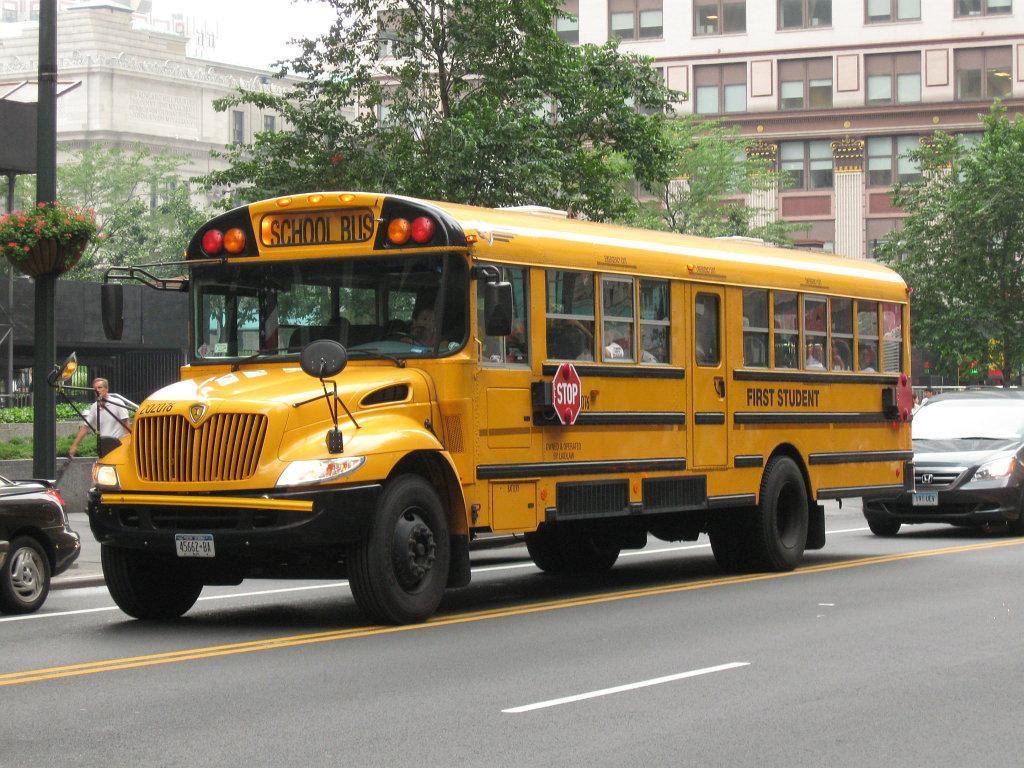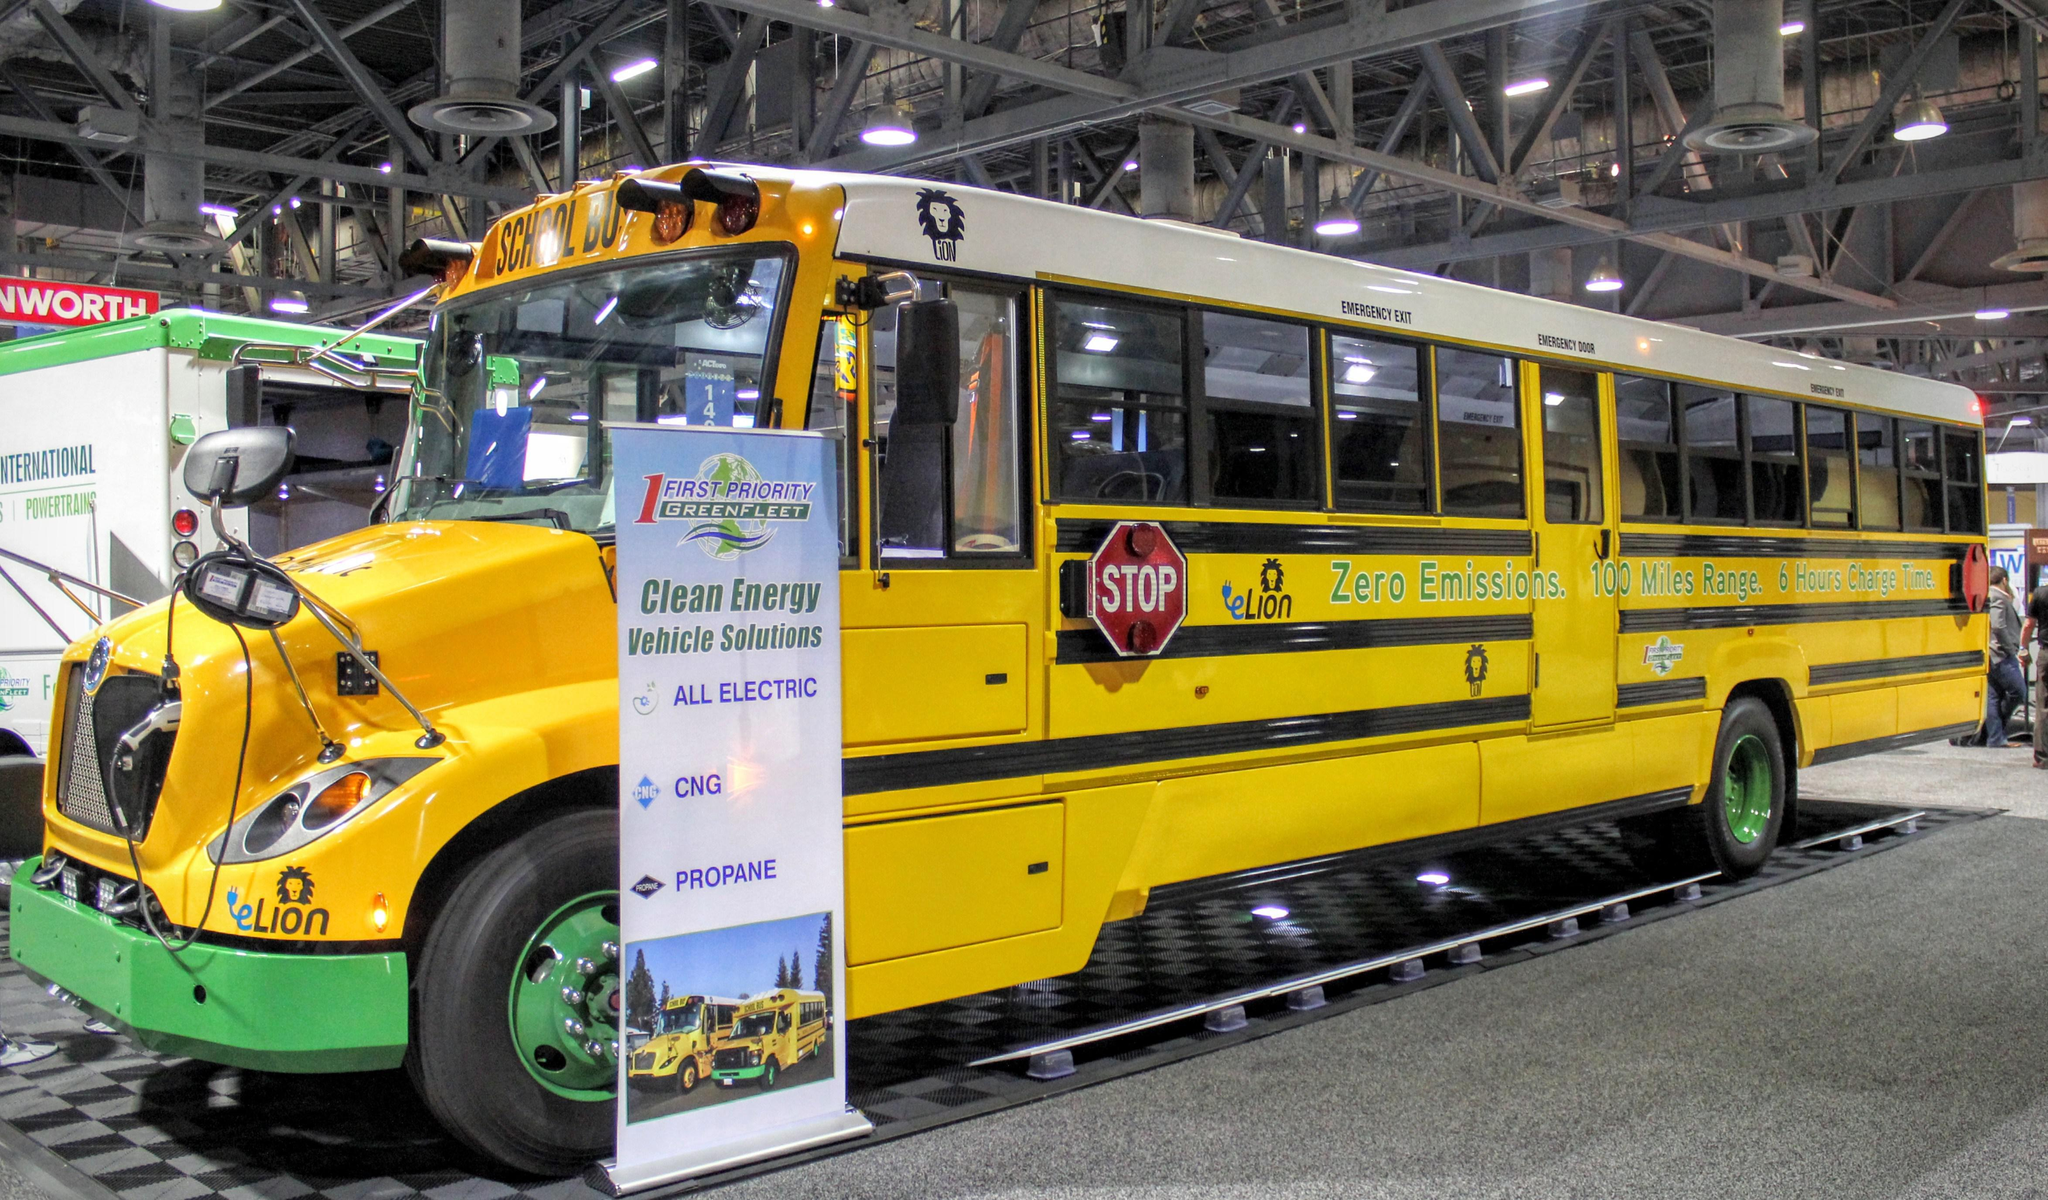The first image is the image on the left, the second image is the image on the right. Given the left and right images, does the statement "There is a school bus on a street with yellow lines and the stopsign on the bus is visible" hold true? Answer yes or no. Yes. The first image is the image on the left, the second image is the image on the right. Assess this claim about the two images: "the left and right image contains the same number of buses.". Correct or not? Answer yes or no. Yes. 